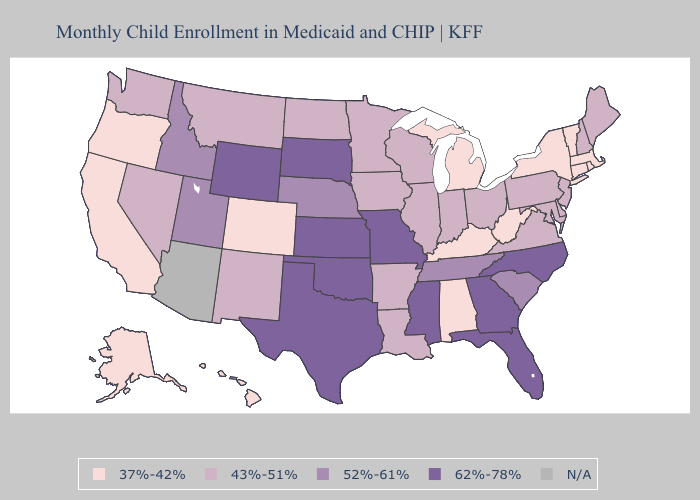Among the states that border Arkansas , which have the lowest value?
Short answer required. Louisiana. What is the highest value in the Northeast ?
Short answer required. 43%-51%. Among the states that border Georgia , which have the highest value?
Short answer required. Florida, North Carolina. Does the first symbol in the legend represent the smallest category?
Give a very brief answer. Yes. Name the states that have a value in the range 62%-78%?
Keep it brief. Florida, Georgia, Kansas, Mississippi, Missouri, North Carolina, Oklahoma, South Dakota, Texas, Wyoming. What is the lowest value in the USA?
Keep it brief. 37%-42%. What is the value of Mississippi?
Write a very short answer. 62%-78%. Among the states that border California , does Oregon have the lowest value?
Write a very short answer. Yes. Does Michigan have the lowest value in the MidWest?
Give a very brief answer. Yes. What is the value of North Dakota?
Answer briefly. 43%-51%. Name the states that have a value in the range 52%-61%?
Give a very brief answer. Idaho, Nebraska, South Carolina, Tennessee, Utah. Does New York have the lowest value in the USA?
Quick response, please. Yes. Among the states that border Oklahoma , does Arkansas have the lowest value?
Write a very short answer. No. Is the legend a continuous bar?
Quick response, please. No. 